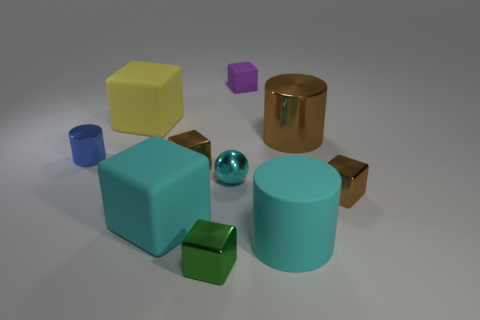Does the ball have the same color as the matte cylinder?
Offer a very short reply. Yes. The tiny metal object behind the tiny brown shiny thing behind the ball is what shape?
Ensure brevity in your answer.  Cylinder. Does the block in front of the cyan block have the same size as the small cylinder?
Keep it short and to the point. Yes. What size is the brown metallic thing that is both behind the cyan shiny sphere and to the right of the cyan cylinder?
Your answer should be compact. Large. What number of green objects have the same size as the blue thing?
Your response must be concise. 1. What number of cyan balls are on the left side of the cylinder that is left of the large yellow object?
Your answer should be very brief. 0. There is a small shiny thing that is on the right side of the small purple thing; is its color the same as the large metal object?
Keep it short and to the point. Yes. Are there any big rubber blocks that are to the right of the tiny brown shiny object left of the tiny cyan metal ball that is in front of the large yellow matte thing?
Your response must be concise. No. There is a large object that is both in front of the yellow thing and behind the small blue metal cylinder; what is its shape?
Make the answer very short. Cylinder. Is there a big object of the same color as the big matte cylinder?
Give a very brief answer. Yes. 